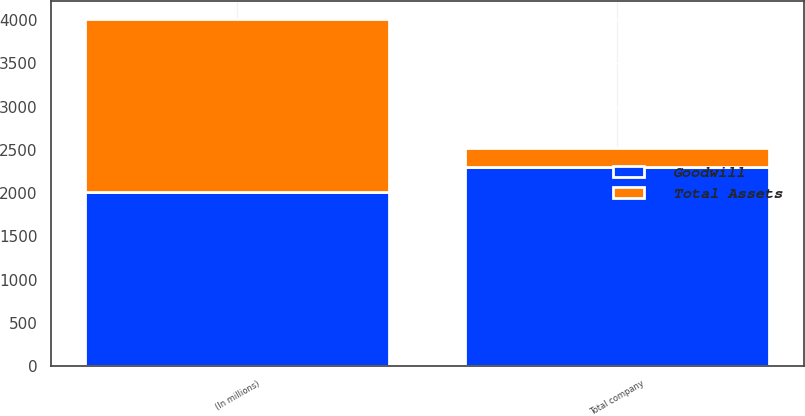<chart> <loc_0><loc_0><loc_500><loc_500><stacked_bar_chart><ecel><fcel>(In millions)<fcel>Total company<nl><fcel>Goodwill<fcel>2009<fcel>2308<nl><fcel>Total Assets<fcel>2009<fcel>210<nl></chart> 